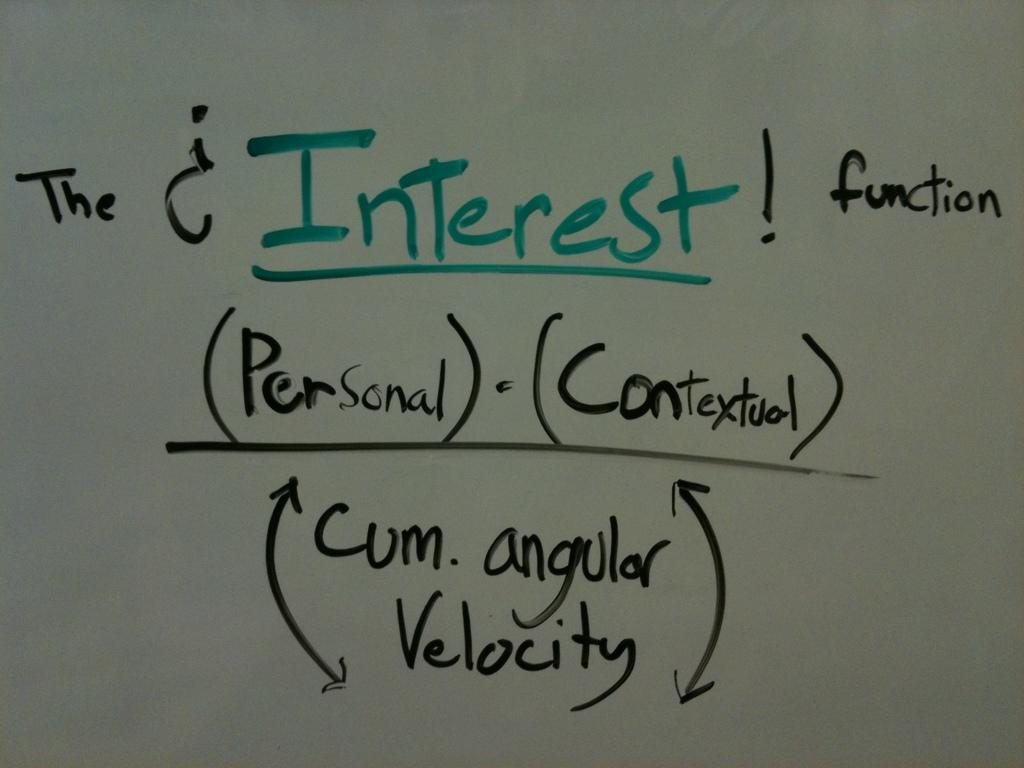Provide a one-sentence caption for the provided image. A white board shows the equation for the Interest Function as (Personal) x (Contextual) / Cum.angular velocity. 